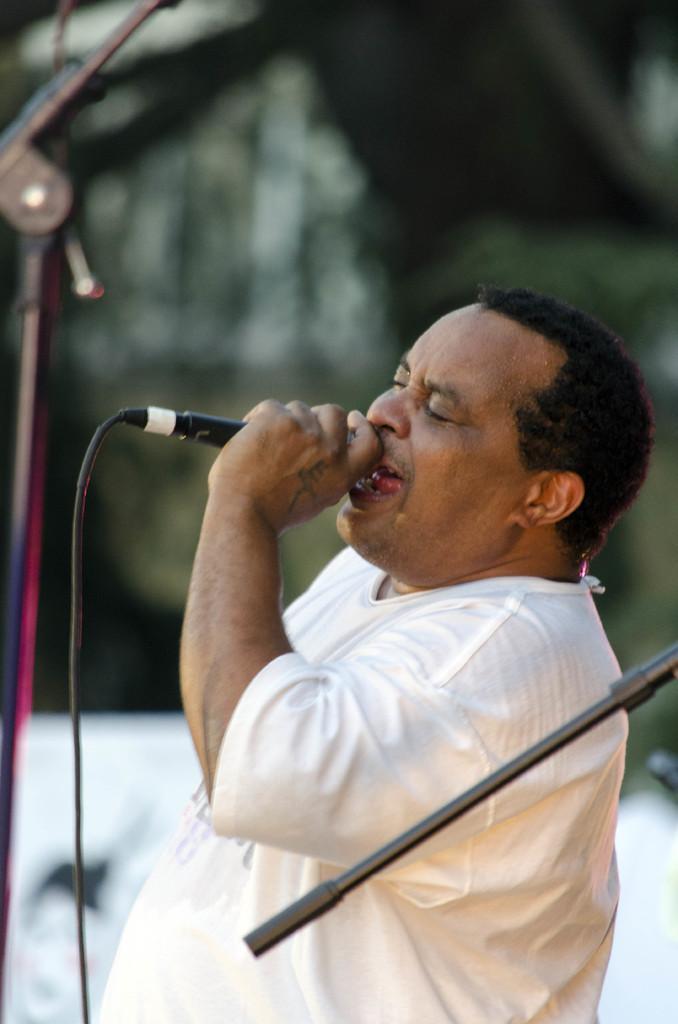How would you summarize this image in a sentence or two? A man is singing with a mic in his hand. 